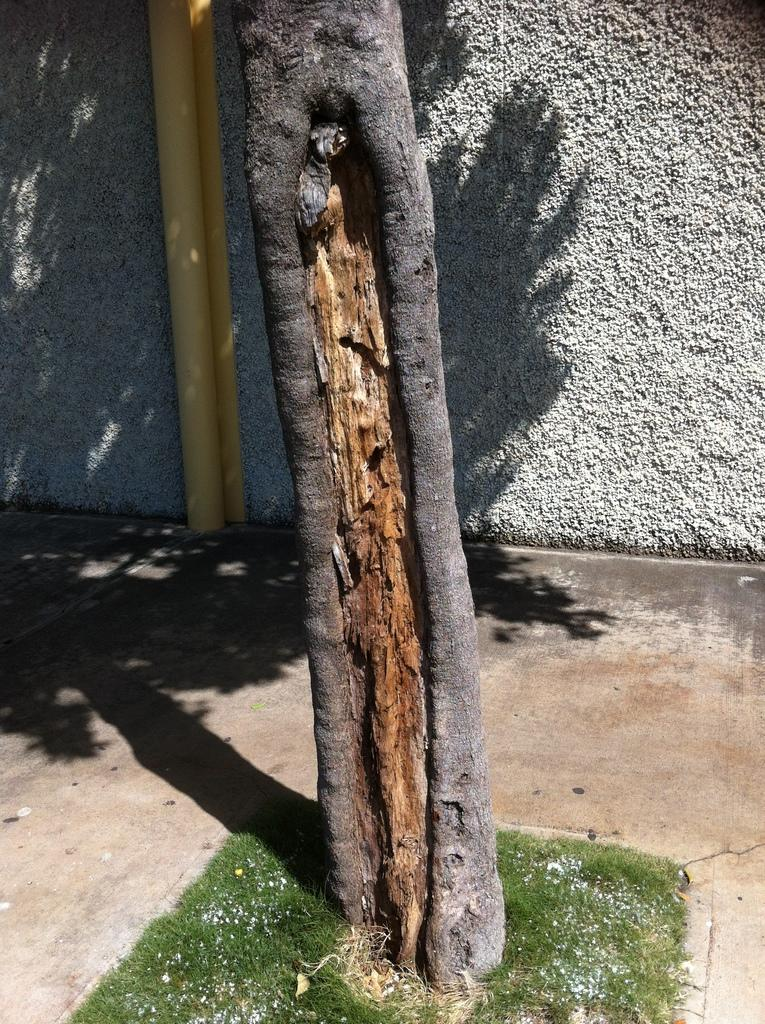What is the main subject in the middle of the image? There is a tree trunk in the middle of the image. What can be seen in the background of the image? There is a wall in the background of the image. Are there any other objects or structures near the wall? Yes, there is a pipe beside the wall. What type of vegetation is present on the ground in the image? There is small grass on the ground in the image. Can you suggest a road that leads to the zoo in the image? There is no road or zoo present in the image; it only features a tree trunk, wall, pipe, and grass. 